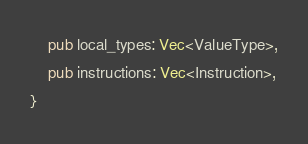<code> <loc_0><loc_0><loc_500><loc_500><_Rust_>    pub local_types: Vec<ValueType>,
    pub instructions: Vec<Instruction>,
}</code> 